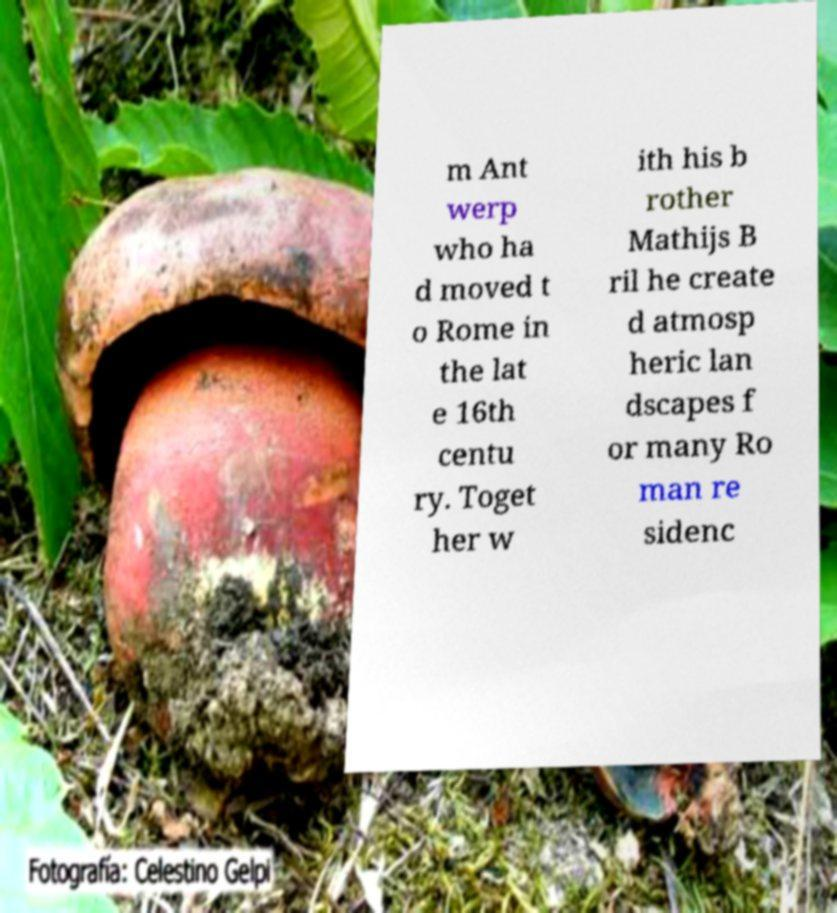Could you extract and type out the text from this image? m Ant werp who ha d moved t o Rome in the lat e 16th centu ry. Toget her w ith his b rother Mathijs B ril he create d atmosp heric lan dscapes f or many Ro man re sidenc 